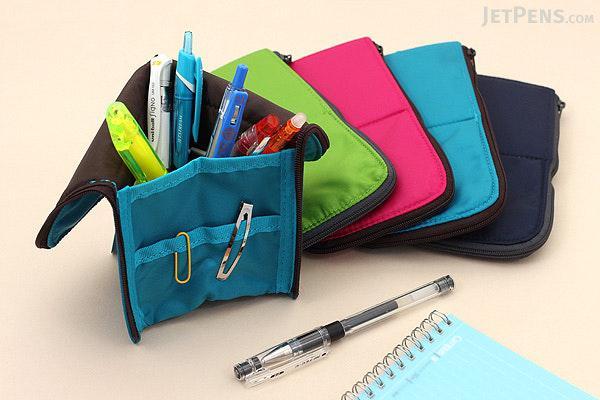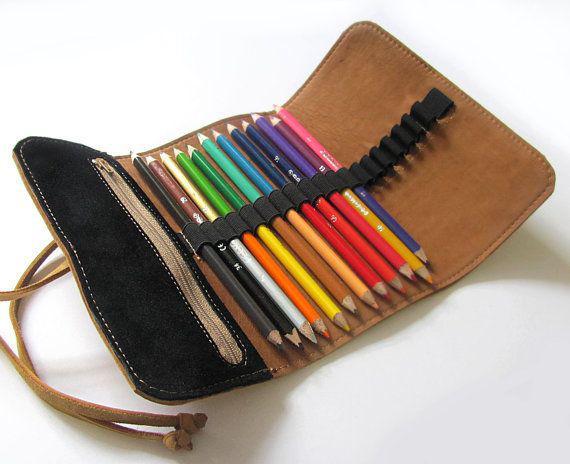The first image is the image on the left, the second image is the image on the right. Considering the images on both sides, is "The right image shows a zipper case with a graphic print on its exterior functioning as an upright holder for colored pencils." valid? Answer yes or no. No. 